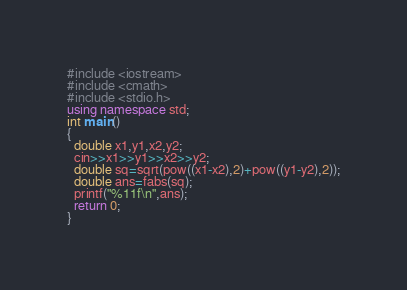Convert code to text. <code><loc_0><loc_0><loc_500><loc_500><_C++_>#include <iostream>
#include <cmath>
#include <stdio.h>
using namespace std;
int main()
{
  double x1,y1,x2,y2;
  cin>>x1>>y1>>x2>>y2;
  double sq=sqrt(pow((x1-x2),2)+pow((y1-y2),2));
  double ans=fabs(sq);
  printf("%11f\n",ans);
  return 0;
}
</code> 